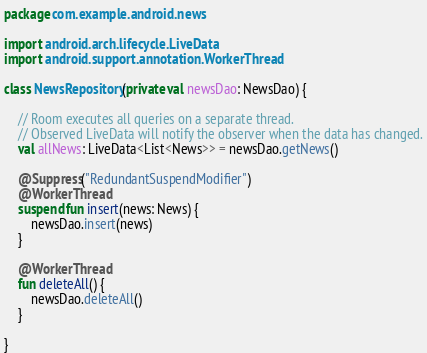Convert code to text. <code><loc_0><loc_0><loc_500><loc_500><_Kotlin_>package com.example.android.news

import android.arch.lifecycle.LiveData
import android.support.annotation.WorkerThread

class NewsRepository(private val newsDao: NewsDao) {

    // Room executes all queries on a separate thread.
    // Observed LiveData will notify the observer when the data has changed.
    val allNews: LiveData<List<News>> = newsDao.getNews()

    @Suppress("RedundantSuspendModifier")
    @WorkerThread
    suspend fun insert(news: News) {
        newsDao.insert(news)
    }

    @WorkerThread
    fun deleteAll() {
        newsDao.deleteAll()
    }

}
</code> 